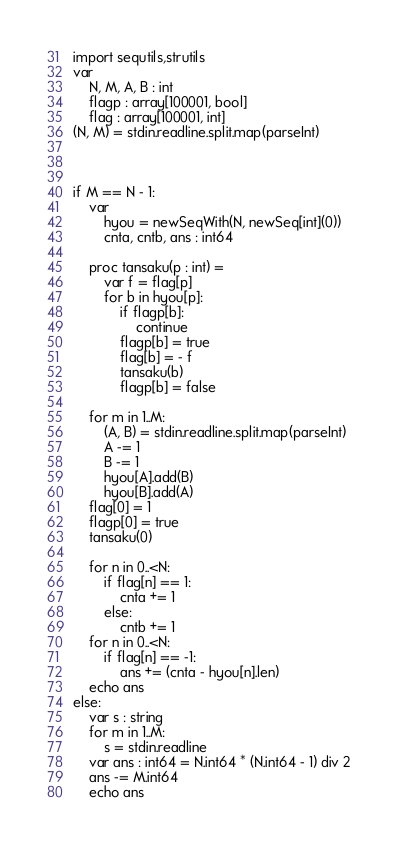<code> <loc_0><loc_0><loc_500><loc_500><_Nim_>import sequtils,strutils
var
    N, M, A, B : int
    flagp : array[100001, bool]
    flag : array[100001, int]
(N, M) = stdin.readline.split.map(parseInt)

        
        
if M == N - 1:
    var
        hyou = newSeqWith(N, newSeq[int](0))
        cnta, cntb, ans : int64
        
    proc tansaku(p : int) =
        var f = flag[p]
        for b in hyou[p]:
            if flagp[b]:
                continue
            flagp[b] = true
            flag[b] = - f
            tansaku(b)
            flagp[b] = false
    
    for m in 1..M:
        (A, B) = stdin.readline.split.map(parseInt)
        A -= 1
        B -= 1
        hyou[A].add(B)
        hyou[B].add(A)
    flag[0] = 1
    flagp[0] = true
    tansaku(0)
    
    for n in 0..<N:
        if flag[n] == 1:
            cnta += 1
        else:
            cntb += 1
    for n in 0..<N:
        if flag[n] == -1:
            ans += (cnta - hyou[n].len)
    echo ans
else:
    var s : string
    for m in 1..M:
        s = stdin.readline
    var ans : int64 = N.int64 * (N.int64 - 1) div 2
    ans -= M.int64
    echo ans</code> 